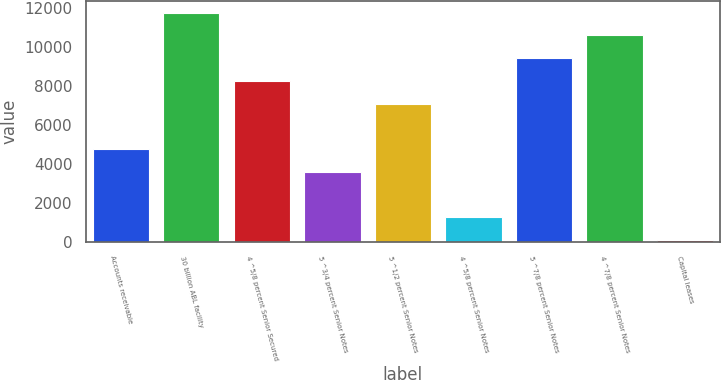<chart> <loc_0><loc_0><loc_500><loc_500><bar_chart><fcel>Accounts receivable<fcel>30 billion ABL facility<fcel>4 ^5/8 percent Senior Secured<fcel>5 ^3/4 percent Senior Notes<fcel>5 ^1/2 percent Senior Notes<fcel>4 ^5/8 percent Senior Notes<fcel>5 ^7/8 percent Senior Notes<fcel>4 ^7/8 percent Senior Notes<fcel>Capital leases<nl><fcel>4772<fcel>11747<fcel>8259.5<fcel>3609.5<fcel>7097<fcel>1284.5<fcel>9422<fcel>10584.5<fcel>122<nl></chart> 